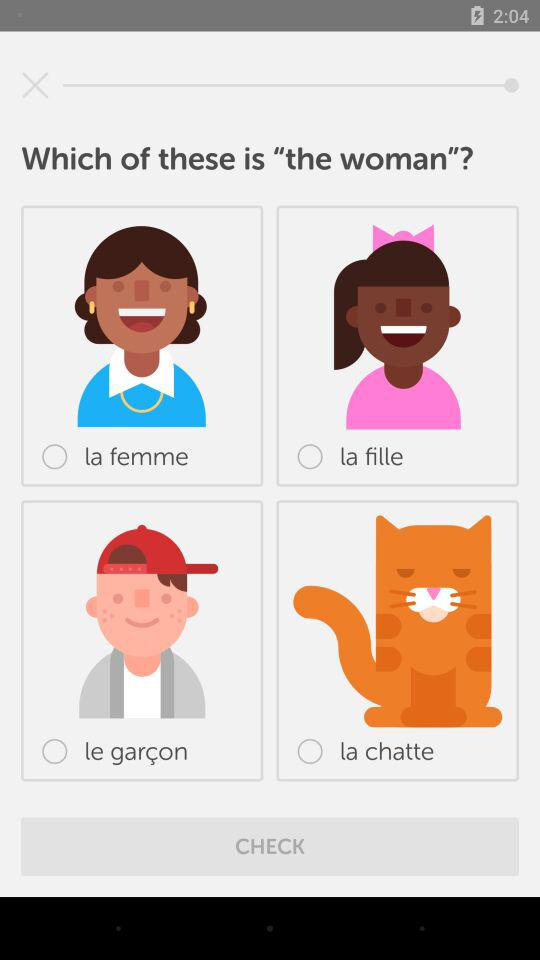How many items are not a woman?
Answer the question using a single word or phrase. 2 